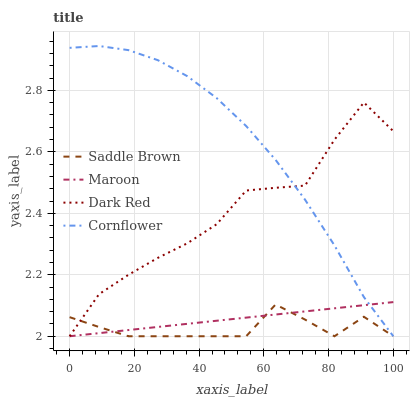Does Saddle Brown have the minimum area under the curve?
Answer yes or no. Yes. Does Cornflower have the maximum area under the curve?
Answer yes or no. Yes. Does Maroon have the minimum area under the curve?
Answer yes or no. No. Does Maroon have the maximum area under the curve?
Answer yes or no. No. Is Maroon the smoothest?
Answer yes or no. Yes. Is Dark Red the roughest?
Answer yes or no. Yes. Is Saddle Brown the smoothest?
Answer yes or no. No. Is Saddle Brown the roughest?
Answer yes or no. No. Does Dark Red have the lowest value?
Answer yes or no. Yes. Does Cornflower have the highest value?
Answer yes or no. Yes. Does Maroon have the highest value?
Answer yes or no. No. Does Dark Red intersect Saddle Brown?
Answer yes or no. Yes. Is Dark Red less than Saddle Brown?
Answer yes or no. No. Is Dark Red greater than Saddle Brown?
Answer yes or no. No. 